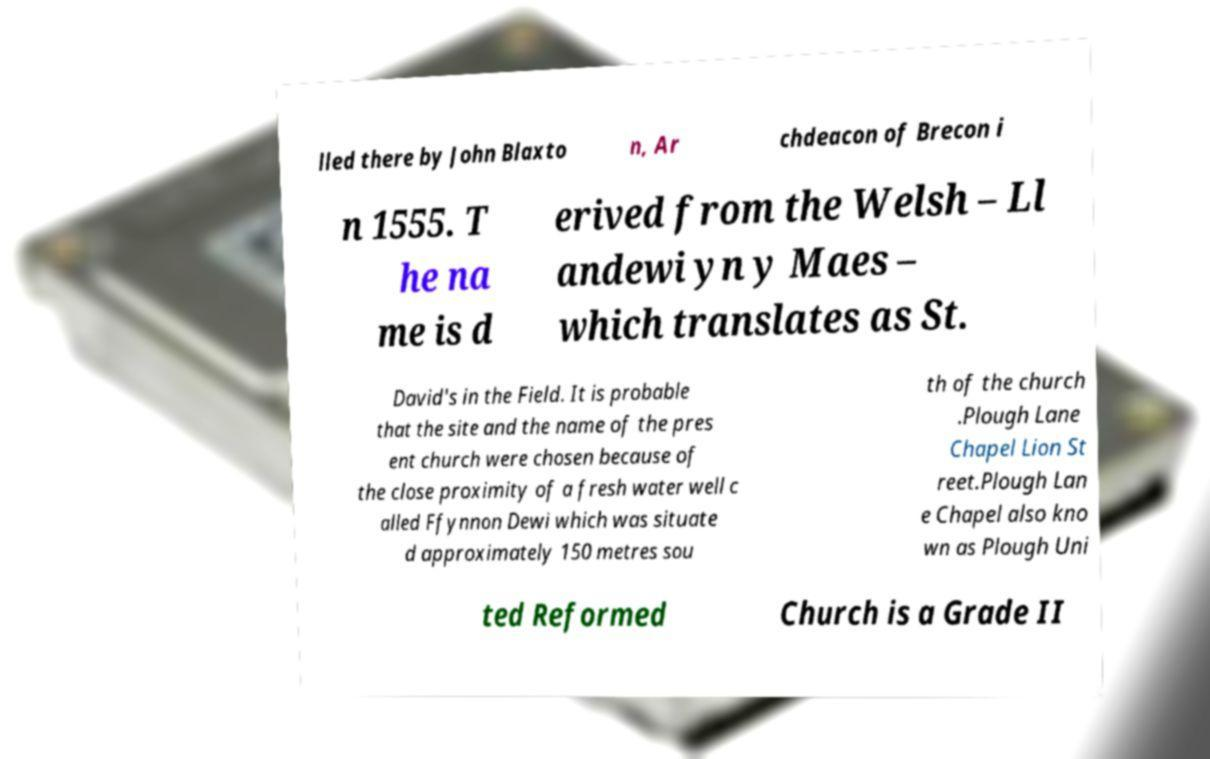I need the written content from this picture converted into text. Can you do that? lled there by John Blaxto n, Ar chdeacon of Brecon i n 1555. T he na me is d erived from the Welsh – Ll andewi yn y Maes – which translates as St. David's in the Field. It is probable that the site and the name of the pres ent church were chosen because of the close proximity of a fresh water well c alled Ffynnon Dewi which was situate d approximately 150 metres sou th of the church .Plough Lane Chapel Lion St reet.Plough Lan e Chapel also kno wn as Plough Uni ted Reformed Church is a Grade II 